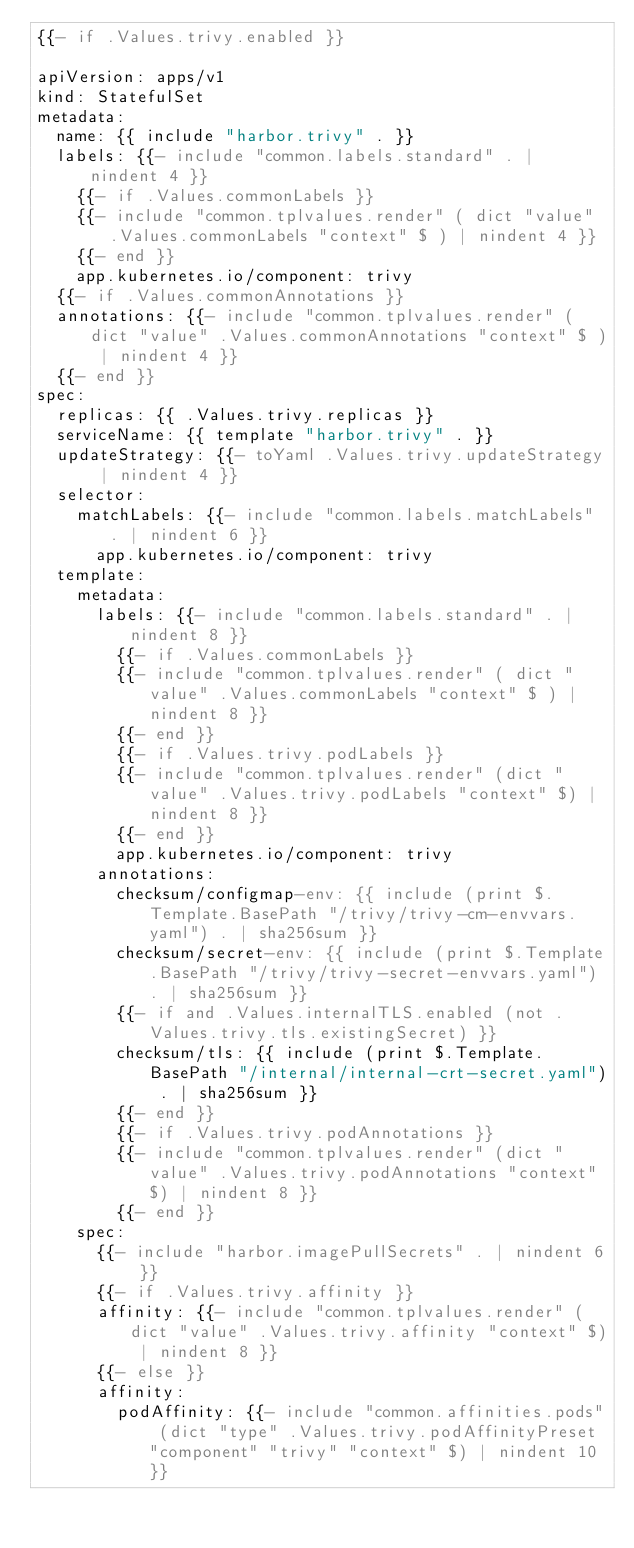Convert code to text. <code><loc_0><loc_0><loc_500><loc_500><_YAML_>{{- if .Values.trivy.enabled }}

apiVersion: apps/v1
kind: StatefulSet
metadata:
  name: {{ include "harbor.trivy" . }}
  labels: {{- include "common.labels.standard" . | nindent 4 }}
    {{- if .Values.commonLabels }}
    {{- include "common.tplvalues.render" ( dict "value" .Values.commonLabels "context" $ ) | nindent 4 }}
    {{- end }}
    app.kubernetes.io/component: trivy
  {{- if .Values.commonAnnotations }}
  annotations: {{- include "common.tplvalues.render" ( dict "value" .Values.commonAnnotations "context" $ ) | nindent 4 }}
  {{- end }}
spec:
  replicas: {{ .Values.trivy.replicas }}
  serviceName: {{ template "harbor.trivy" . }}
  updateStrategy: {{- toYaml .Values.trivy.updateStrategy | nindent 4 }}
  selector:
    matchLabels: {{- include "common.labels.matchLabels" . | nindent 6 }}
      app.kubernetes.io/component: trivy
  template:
    metadata:
      labels: {{- include "common.labels.standard" . | nindent 8 }}
        {{- if .Values.commonLabels }}
        {{- include "common.tplvalues.render" ( dict "value" .Values.commonLabels "context" $ ) | nindent 8 }}
        {{- end }}
        {{- if .Values.trivy.podLabels }}
        {{- include "common.tplvalues.render" (dict "value" .Values.trivy.podLabels "context" $) | nindent 8 }}
        {{- end }}
        app.kubernetes.io/component: trivy
      annotations:
        checksum/configmap-env: {{ include (print $.Template.BasePath "/trivy/trivy-cm-envvars.yaml") . | sha256sum }}
        checksum/secret-env: {{ include (print $.Template.BasePath "/trivy/trivy-secret-envvars.yaml") . | sha256sum }}
        {{- if and .Values.internalTLS.enabled (not .Values.trivy.tls.existingSecret) }}
        checksum/tls: {{ include (print $.Template.BasePath "/internal/internal-crt-secret.yaml") . | sha256sum }}
        {{- end }}
        {{- if .Values.trivy.podAnnotations }}
        {{- include "common.tplvalues.render" (dict "value" .Values.trivy.podAnnotations "context" $) | nindent 8 }}
        {{- end }}
    spec:
      {{- include "harbor.imagePullSecrets" . | nindent 6 }}
      {{- if .Values.trivy.affinity }}
      affinity: {{- include "common.tplvalues.render" (dict "value" .Values.trivy.affinity "context" $) | nindent 8 }}
      {{- else }}
      affinity:
        podAffinity: {{- include "common.affinities.pods" (dict "type" .Values.trivy.podAffinityPreset "component" "trivy" "context" $) | nindent 10 }}</code> 